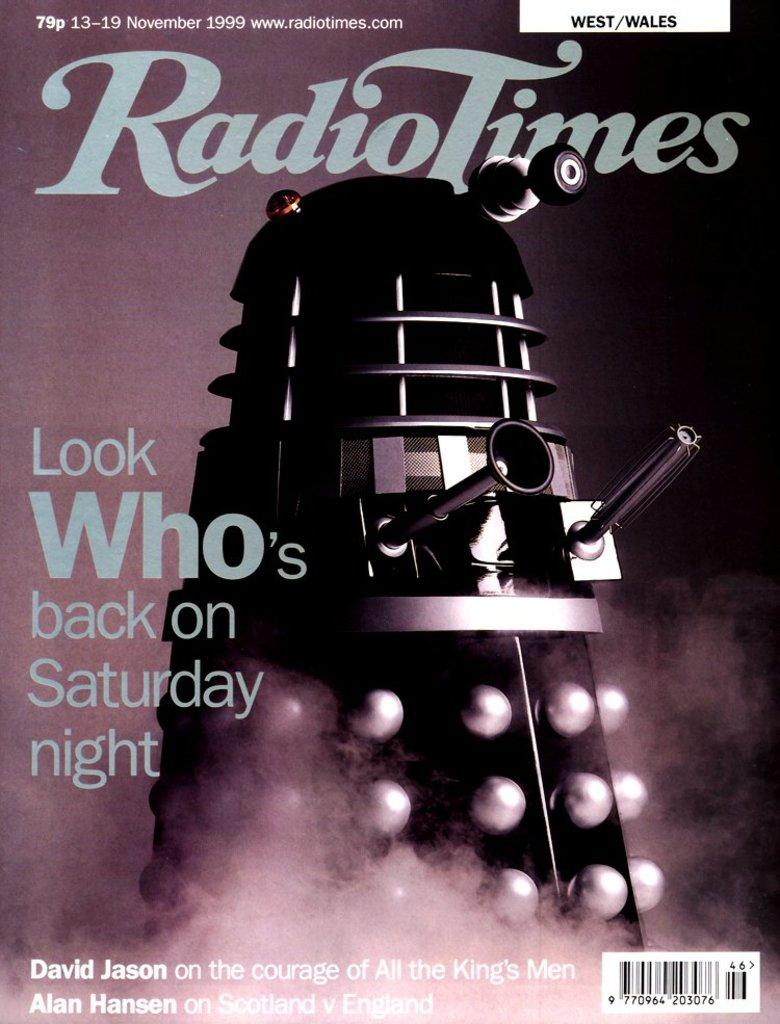<image>
Write a terse but informative summary of the picture. A magazine cover by the name of Radio Times 